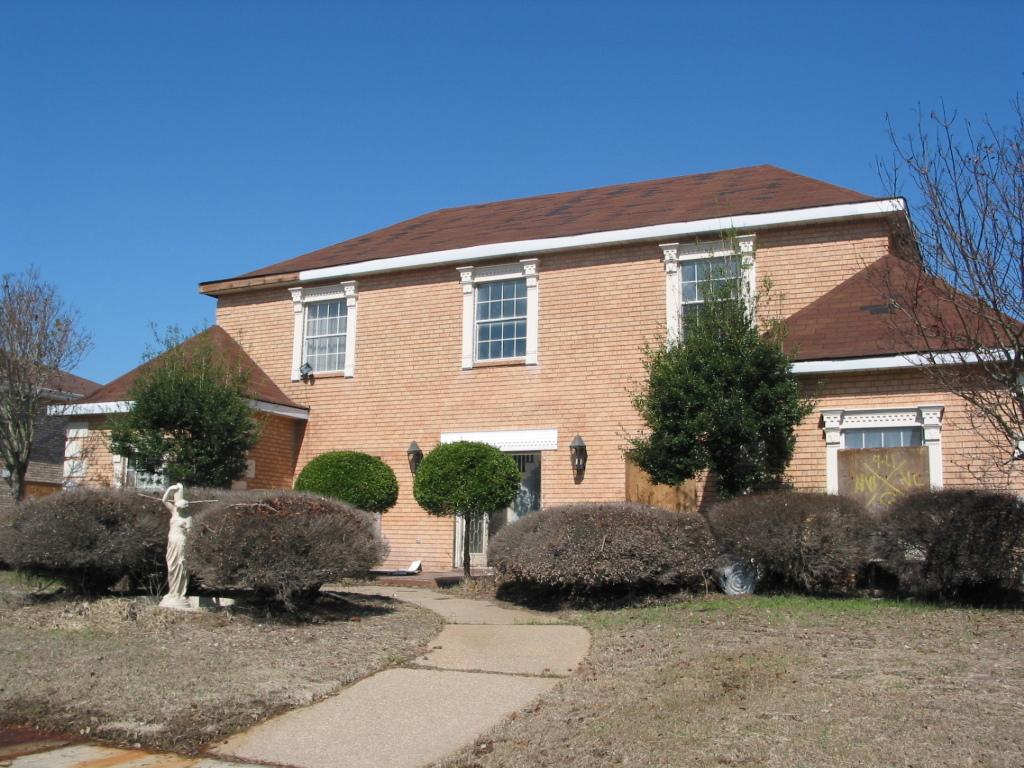What type of vegetation can be seen in the image? There is grass and plants in the image. What is the main object in the image? There is a statue in the image. What is the path used for in the image? The path is likely used for walking or traveling through the area. What type of structures are visible in the image? There are houses in the image. What type of trees are present in the image? There are trees in the image. What are the lights attached to the wall used for? The lights attached to the wall are likely used for illumination. What can be seen in the background of the image? The sky is visible in the background of the image. Can you tell me how many people are fighting in the image? There are no people or fights depicted in the image. What type of need is being used by the person in the image? There are no people or needles present in the image. 